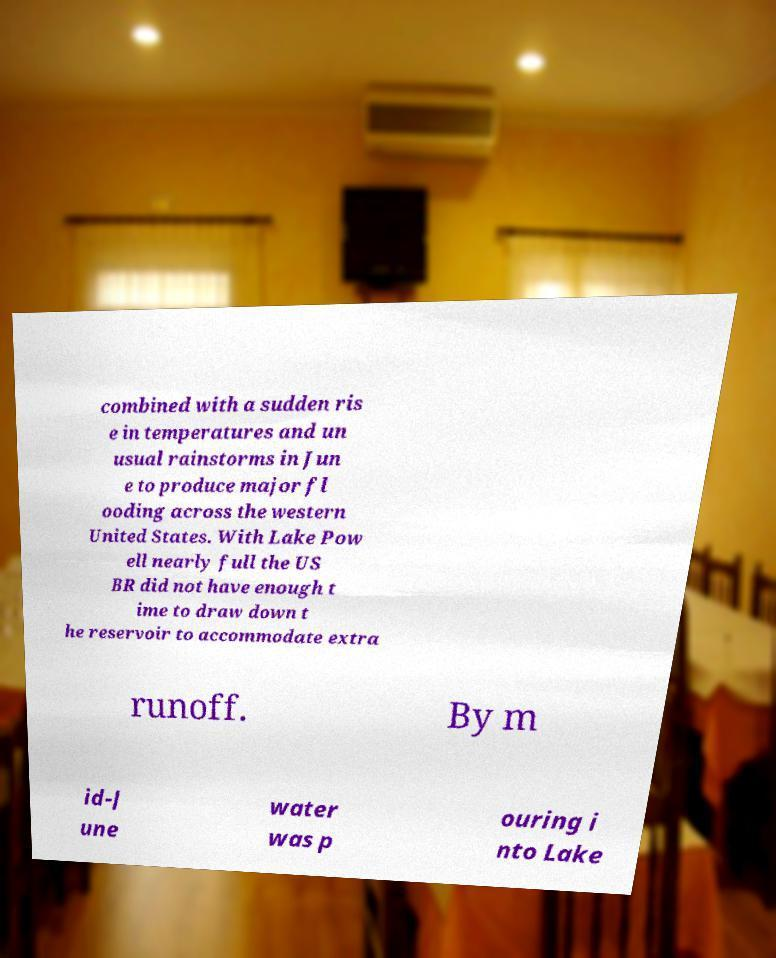Please identify and transcribe the text found in this image. combined with a sudden ris e in temperatures and un usual rainstorms in Jun e to produce major fl ooding across the western United States. With Lake Pow ell nearly full the US BR did not have enough t ime to draw down t he reservoir to accommodate extra runoff. By m id-J une water was p ouring i nto Lake 